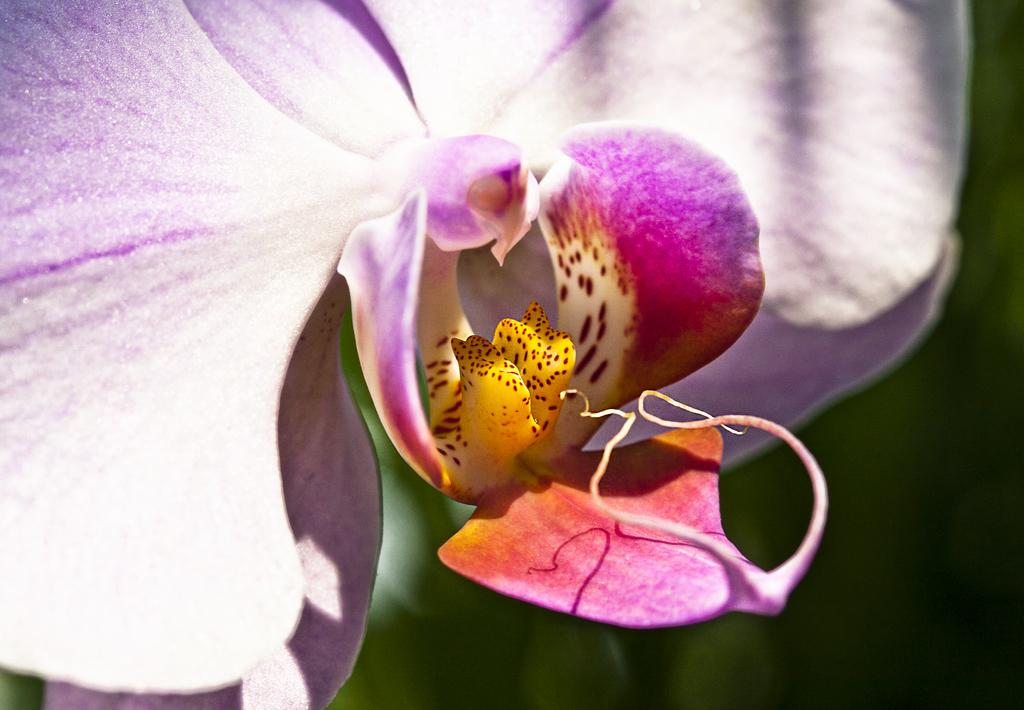What is the main subject of the image? The main subject of the image is a flower. Can you describe the color of the flower? The flower is purple. What type of government is represented by the flag in the image? There is no flag present in the image, so it is not possible to determine the type of government represented. 